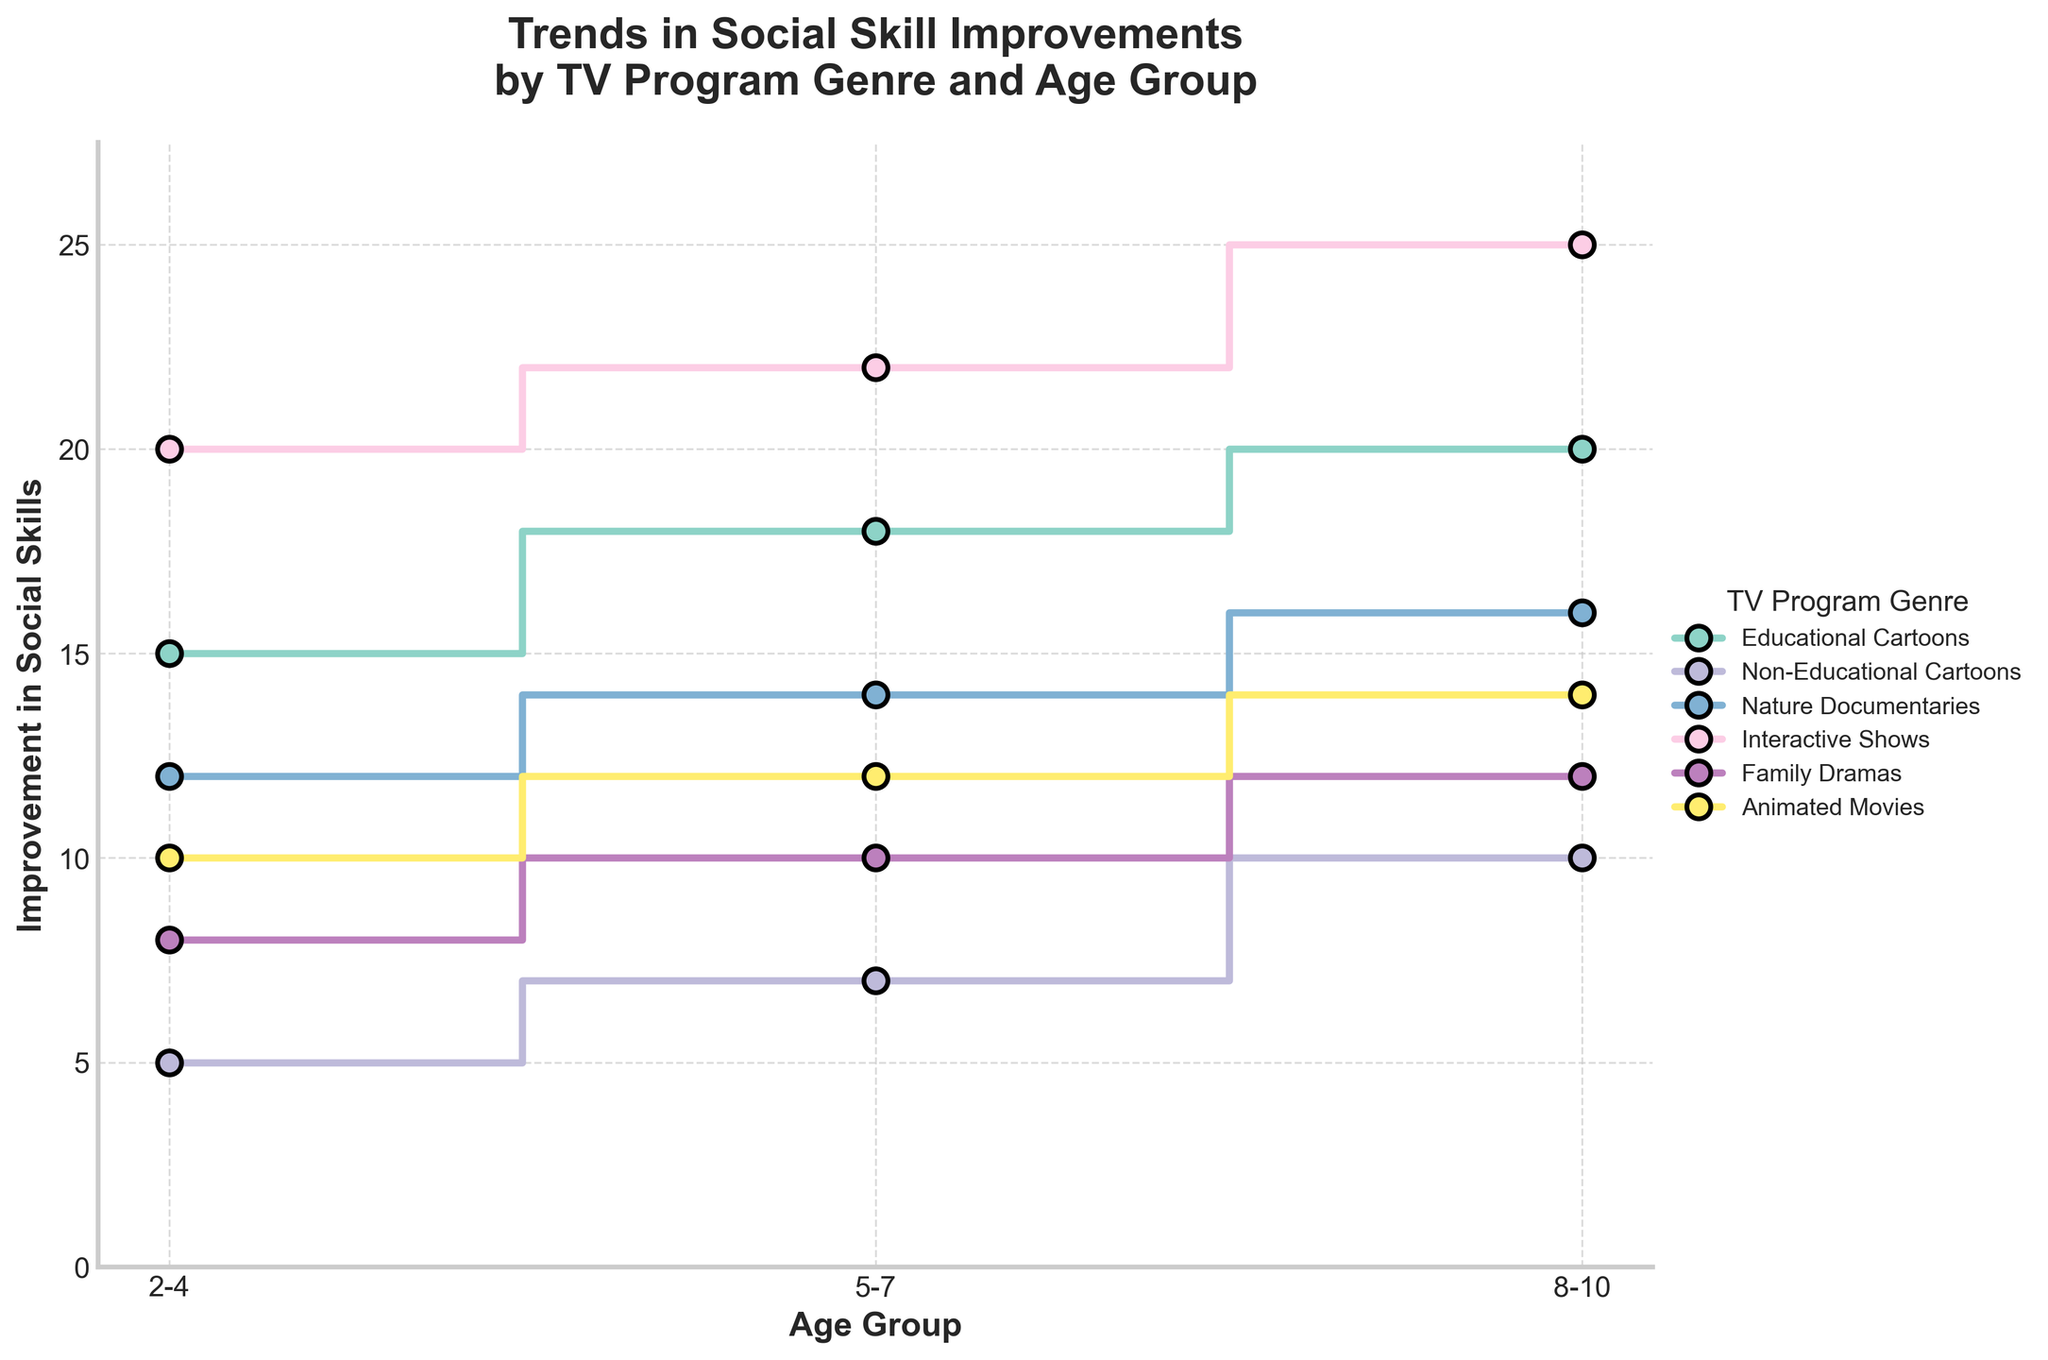What genre demonstrates the greatest improvement in social skills for the age group 8-10? The step plot shows that the genre with the highest point at the age group 8-10 is 'Interactive Shows' at 25.
Answer: Interactive Shows Which age group shows the least improvement in social skills when watching Non-Educational Cartoons? By examining the plot, the lowest point for Non-Educational Cartoons is at the age group 2-4 with an improvement value of 5.
Answer: 2-4 How does the social skill improvement for Educational Cartoons compare to Nature Documentaries in the age group 5-7? For the age group 5-7, Educational Cartoons show an improvement value of 18, whereas Nature Documentaries show a value of 14. Hence, Educational Cartoons have a greater improvement.
Answer: Educational Cartoons show greater improvement Which genres exhibit an increasing trend in social skill improvements across all age groups? By looking at each genre's plotted line, 'Educational Cartoons', 'Nature Documentaries', 'Interactive Shows', 'Family Dramas', and 'Animated Movies' exhibit an increasing trend from age group 2-4 to 8-10.
Answer: Educational Cartoons, Nature Documentaries, Interactive Shows, Family Dramas, Animated Movies For the age group 5-7, what is the total improvement in social skills for all genres combined? Summing the values for all genres at the age group 5-7: Educational Cartoons (18) + Non-Educational Cartoons (7) + Nature Documentaries (14) + Interactive Shows (22) + Family Dramas (10) + Animated Movies (12) = 83.
Answer: 83 In which age group do Interactive Shows show the largest improvement in social skills? From the plot, the value for Interactive Shows increases across all age groups, with the highest value of 25 observed in the age group 8-10.
Answer: 8-10 Which genre has the smallest improvement in social skills for the age group 2-4? By observing the plot, the smallest value for age group 2-4 is for Non-Educational Cartoons with an improvement of 5.
Answer: Non-Educational Cartoons Compare the improvement in social skills for Family Dramas and Animated Movies in the age group 5-7. Which genre performs better? For the age group 5-7, Family Dramas show an improvement value of 10, while Animated Movies show a value of 12, indicating Animated Movies perform better.
Answer: Animated Movies Does any genre show a decrease in social skills improvement with increasing age groups? Checking each genre's line plot, no genre demonstrates a decrease; all lines are non-decreasing with age groups.
Answer: No Which genre shows the highest initial (2-4 age group) improvement in social skills? The plot shows that Interactive Shows have the highest initial improvement value of 20 for the 2-4 age group.
Answer: Interactive Shows 